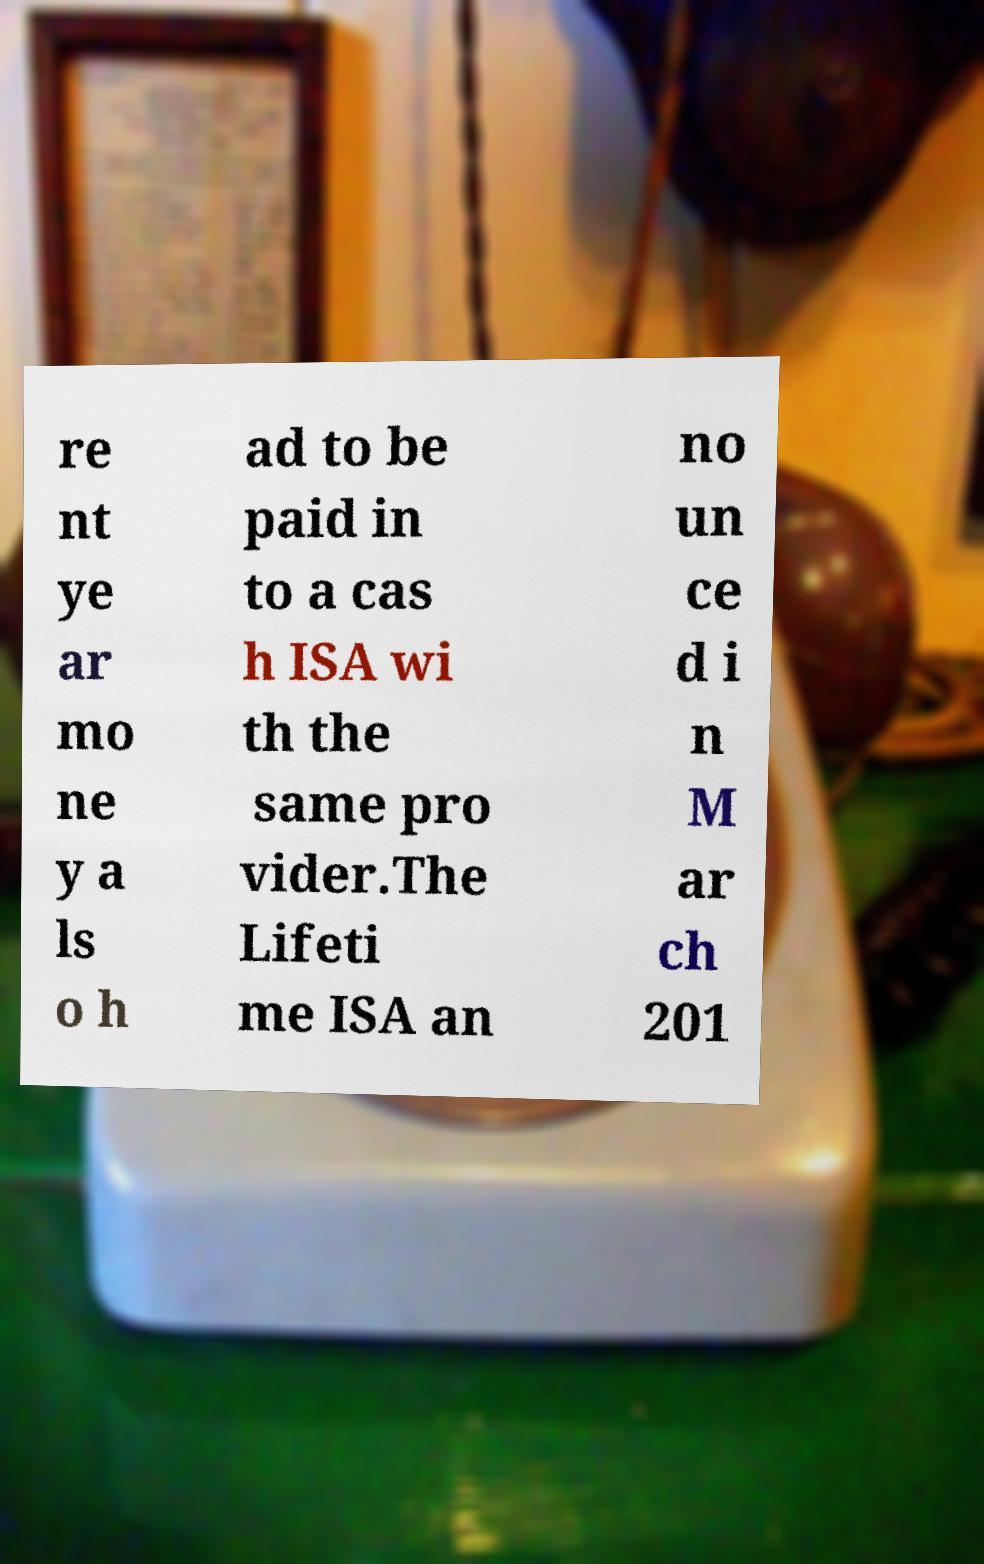Could you extract and type out the text from this image? re nt ye ar mo ne y a ls o h ad to be paid in to a cas h ISA wi th the same pro vider.The Lifeti me ISA an no un ce d i n M ar ch 201 